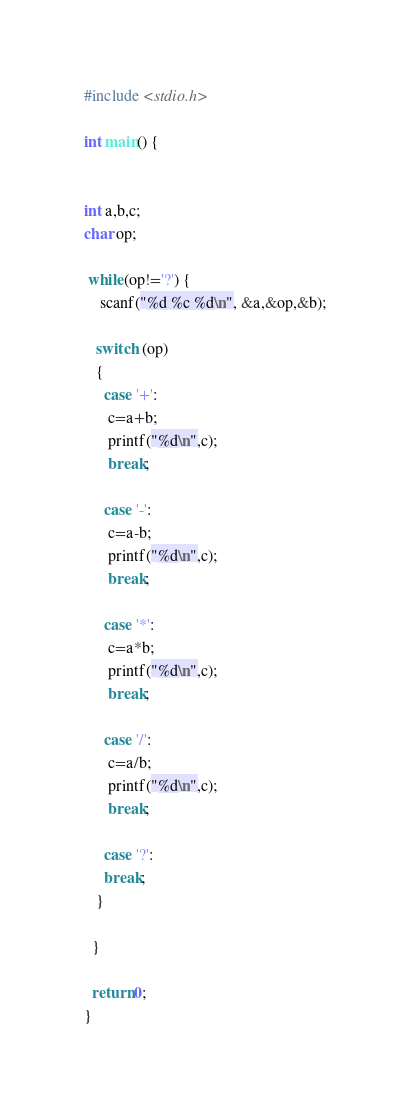Convert code to text. <code><loc_0><loc_0><loc_500><loc_500><_C_>#include <stdio.h>

int main() {


int a,b,c;
char op;

 while(op!='?') {
    scanf("%d %c %d\n", &a,&op,&b);
   
   switch (op) 
   {
     case '+':
      c=a+b;
      printf("%d\n",c);
      break;
      
     case '-':
      c=a-b;
      printf("%d\n",c);
      break;
      
     case '*':
      c=a*b;
      printf("%d\n",c);
      break;
      
     case '/':
      c=a/b;
      printf("%d\n",c);
      break;
      
     case '?':
     break;
   }  
  
  }

  return 0;
}
</code> 